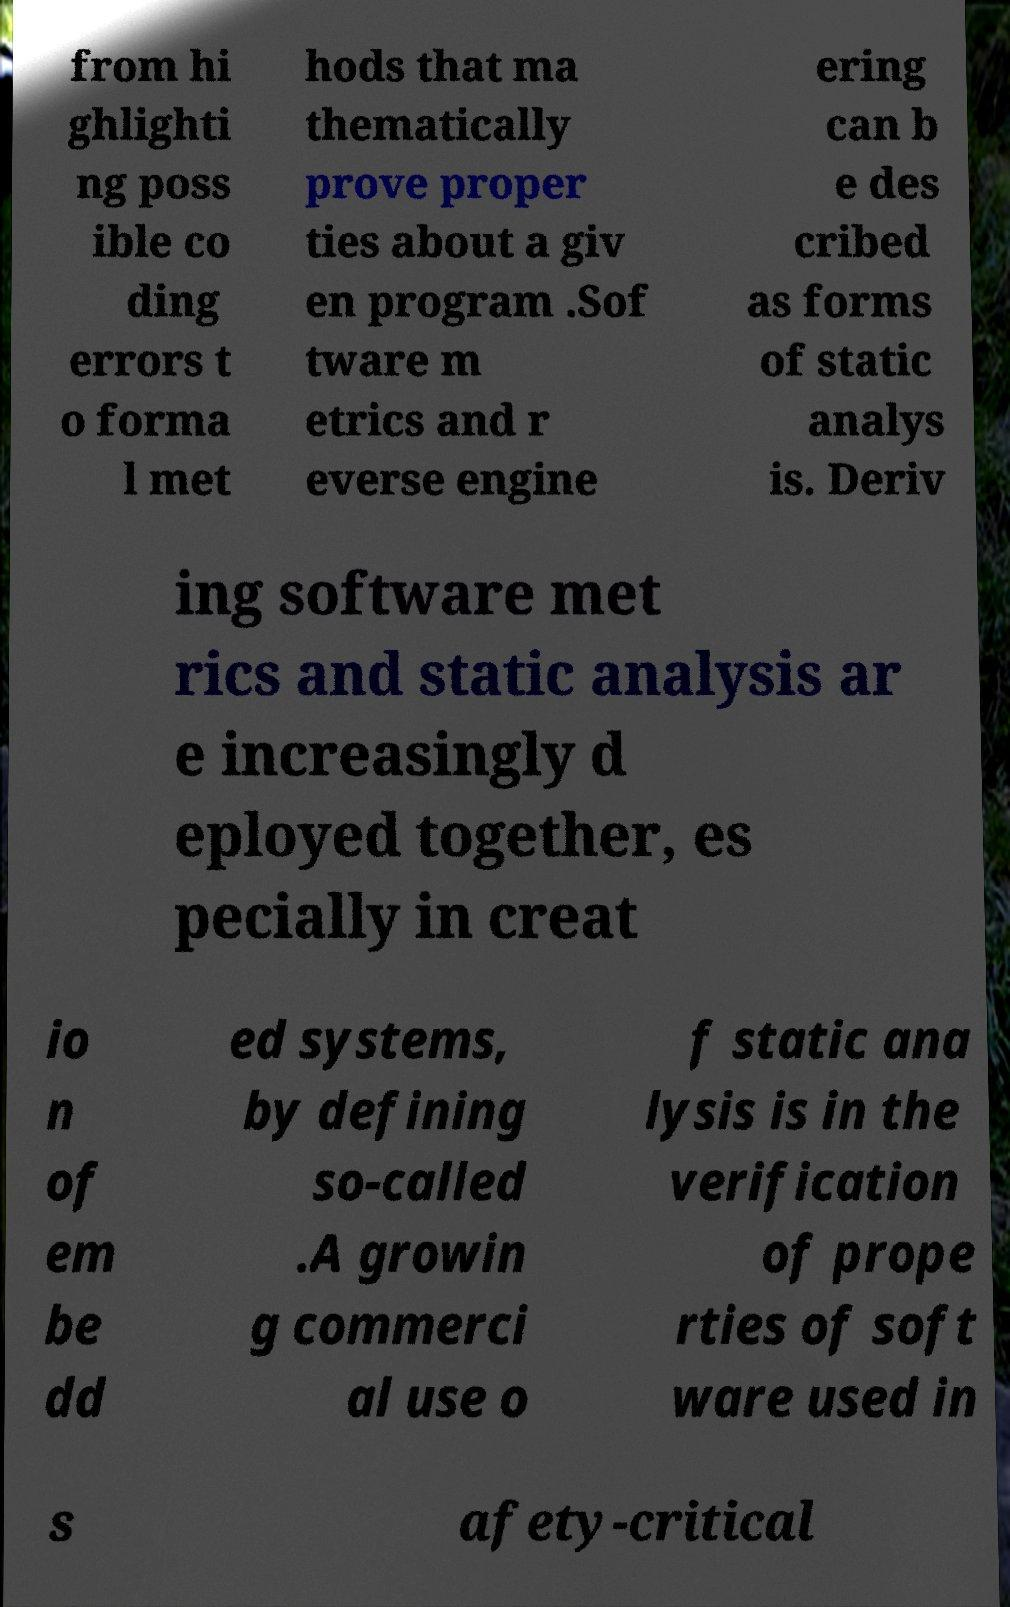For documentation purposes, I need the text within this image transcribed. Could you provide that? from hi ghlighti ng poss ible co ding errors t o forma l met hods that ma thematically prove proper ties about a giv en program .Sof tware m etrics and r everse engine ering can b e des cribed as forms of static analys is. Deriv ing software met rics and static analysis ar e increasingly d eployed together, es pecially in creat io n of em be dd ed systems, by defining so-called .A growin g commerci al use o f static ana lysis is in the verification of prope rties of soft ware used in s afety-critical 